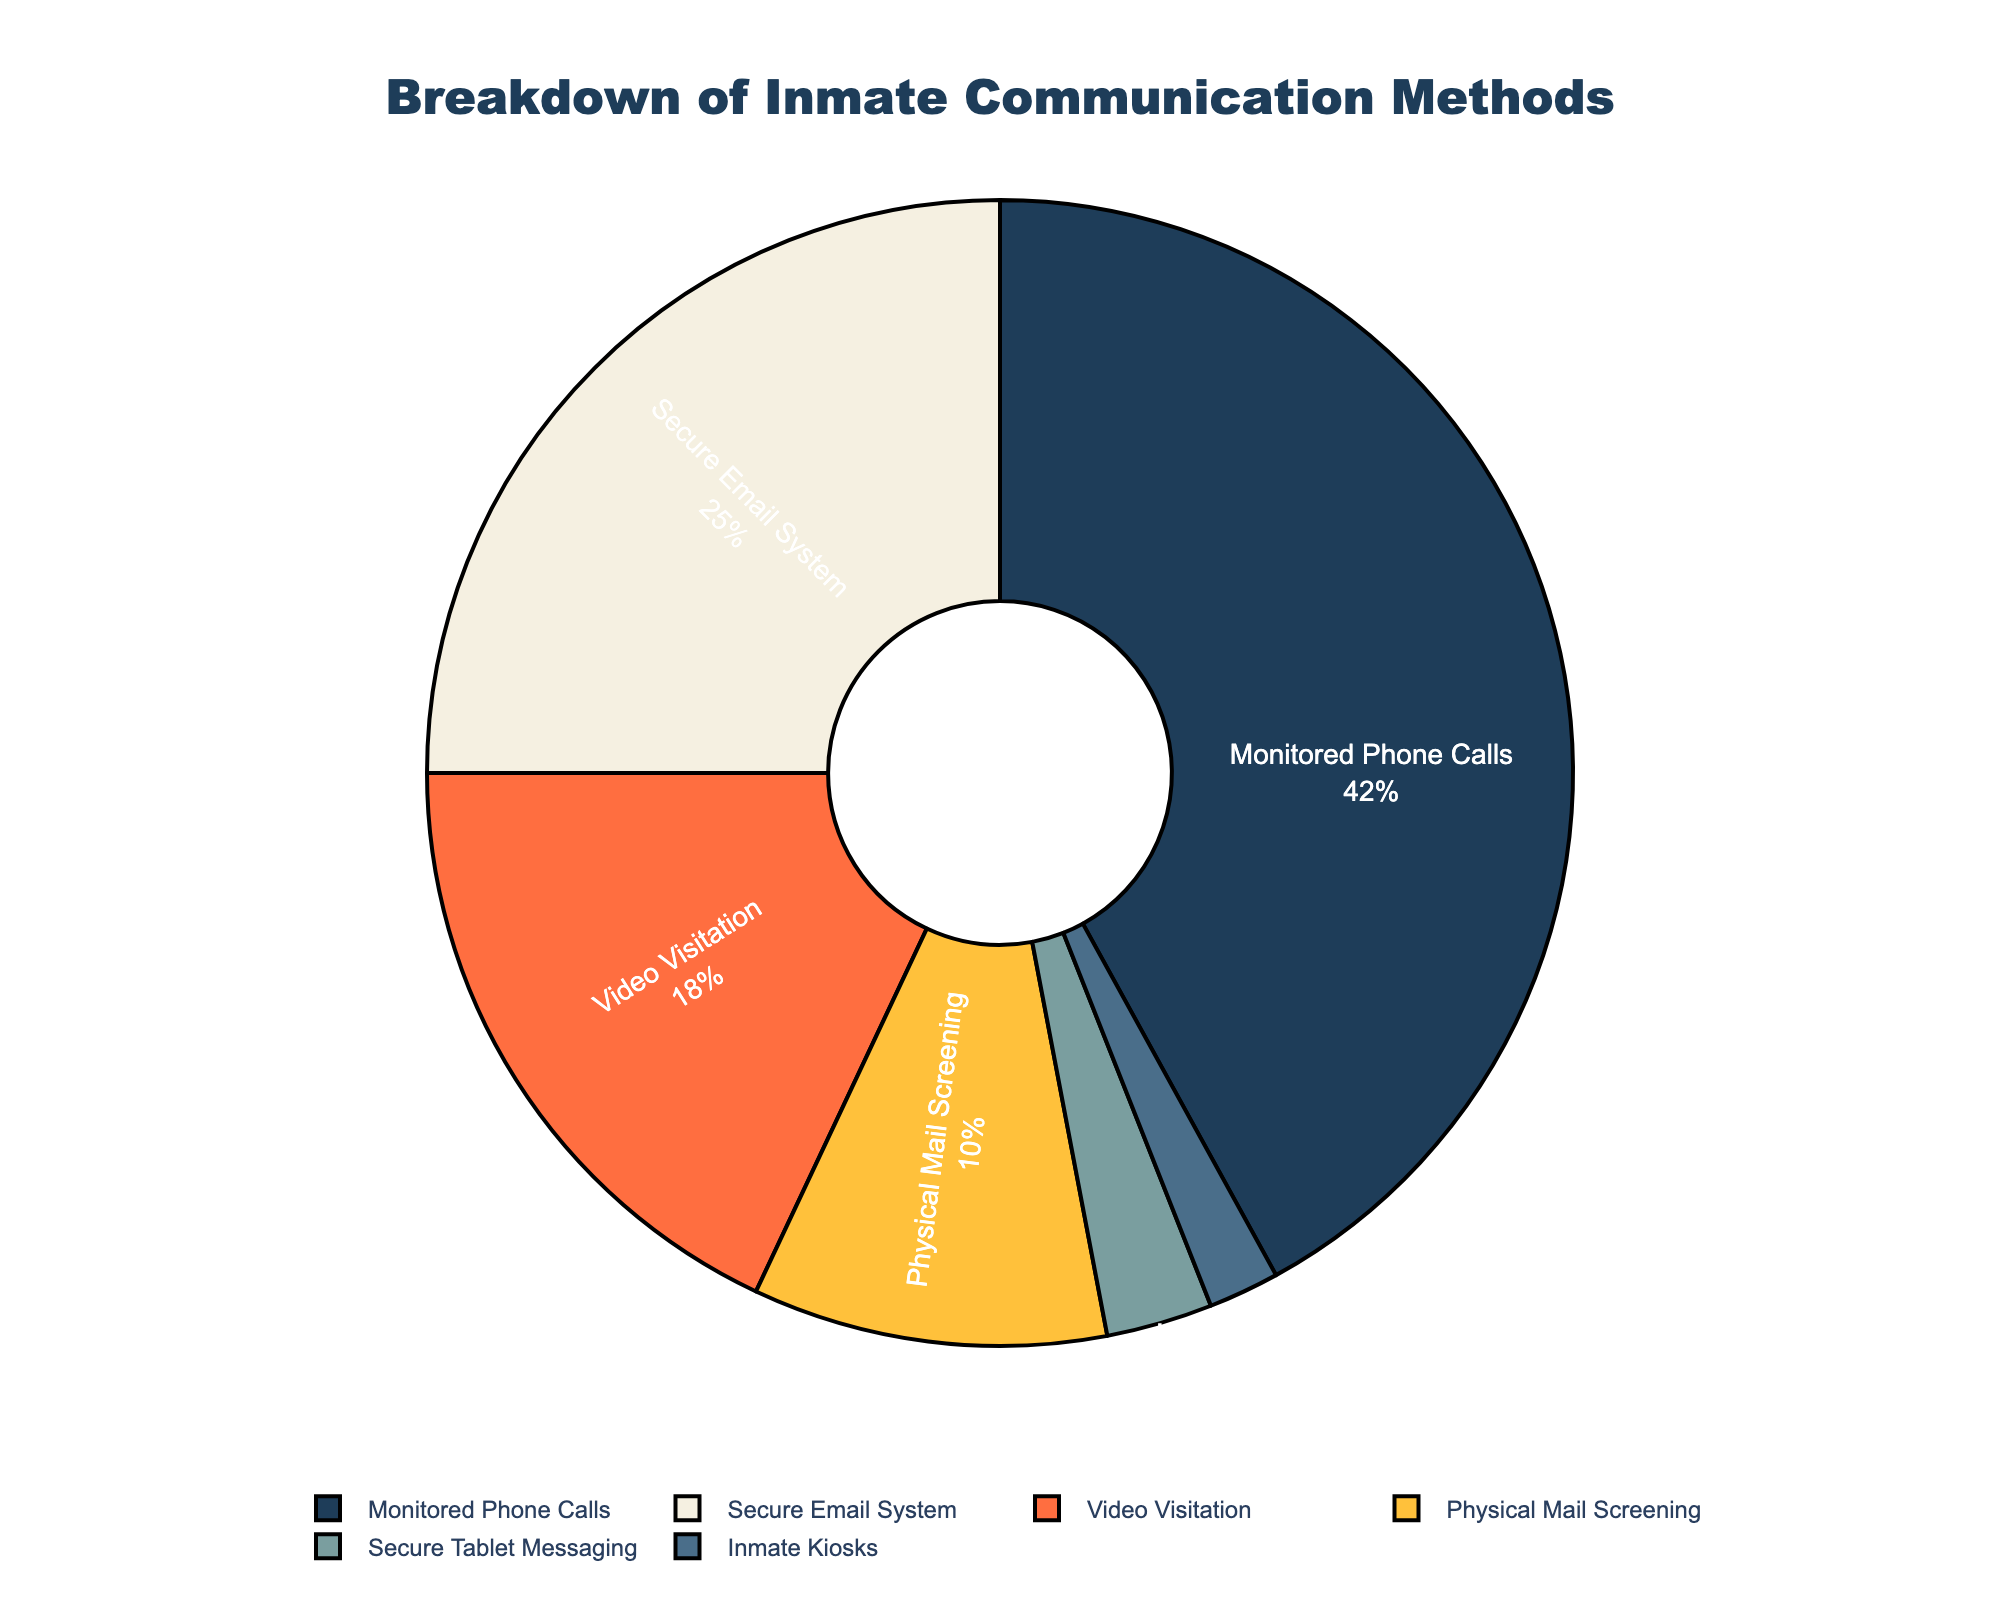What is the most common communication method monitored in prisons, according to the pie chart? The most common communication method can be identified by finding the segment with the highest percentage. From the pie chart, "Monitored Phone Calls" has the largest segment at 42%.
Answer: Monitored Phone Calls Which communication method is used the least according to the chart? To find the least used communication method, look for the segment with the smallest percentage. The pie chart shows "Inmate Kiosks" with only 2%.
Answer: Inmate Kiosks What is the total percentage of communication methods that use digital means (i.e., secure email system, video visitation, secure tablet messaging, and inmate kiosks)? Sum up the percentages for all digital communication methods: Secure Email System (25%) + Video Visitation (18%) + Secure Tablet Messaging (3%) + Inmate Kiosks (2%) = 48%.
Answer: 48% Which has a higher percentage: Secure Email System or Physical Mail Screening? Compare the percentages of the two methods. Secure Email System has 25%, while Physical Mail Screening has 10%. Thus, Secure Email System has a higher percentage.
Answer: Secure Email System How much more prevalent are monitored phone calls compared to video visitation? Subtract the percentage of Video Visitation from Monitored Phone Calls: 42% - 18% = 24%.
Answer: 24% What is the combined percentage of monitored phone calls and secure email system? Sum the percentages of Monitored Phone Calls and Secure Email System: 42% + 25% = 67%.
Answer: 67% Which communication method occupies the largest segment in blue color? Identify the method associated with the blue segment. The pie chart uses blue for "Monitored Phone Calls," which represents the largest segment.
Answer: Monitored Phone Calls What percentage of communication methods involve real-time interaction (i.e., monitored phone calls and video visitation)? Sum the percentages of Monitored Phone Calls and Video Visitation: 42% + 18% = 60%.
Answer: 60% What is the difference in percentage between the Secure Tablet Messaging and Physical Mail Screening methods? Subtract the percentage of Secure Tablet Messaging from Physical Mail Screening: 10% - 3% = 7%.
Answer: 7% If you combine all non-digital communication methods (Monitored Phone Calls and Physical Mail Screening), what is their total percentage? Sum the percentages of Monitored Phone Calls and Physical Mail Screening: 42% + 10% = 52%.
Answer: 52% 